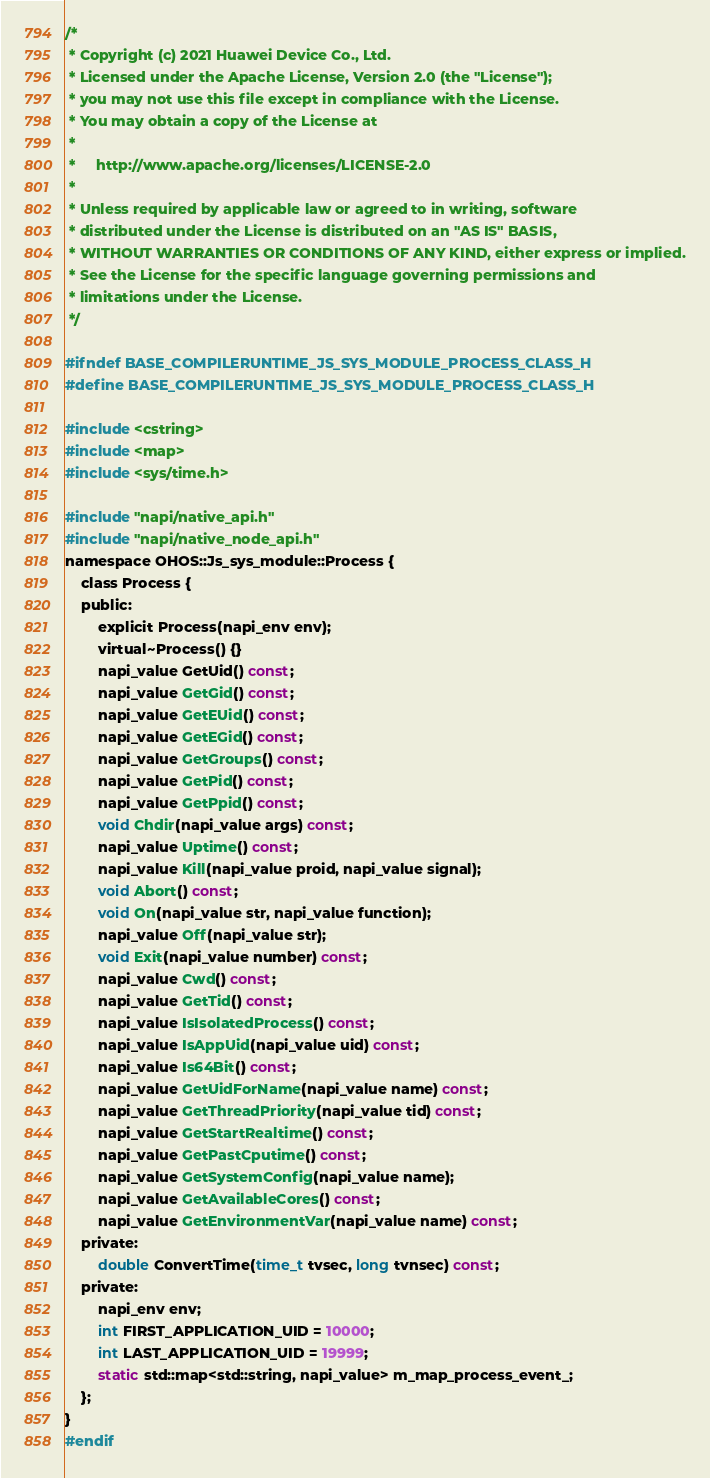Convert code to text. <code><loc_0><loc_0><loc_500><loc_500><_C_>/*
 * Copyright (c) 2021 Huawei Device Co., Ltd.
 * Licensed under the Apache License, Version 2.0 (the "License");
 * you may not use this file except in compliance with the License.
 * You may obtain a copy of the License at
 *
 *     http://www.apache.org/licenses/LICENSE-2.0
 *
 * Unless required by applicable law or agreed to in writing, software
 * distributed under the License is distributed on an "AS IS" BASIS,
 * WITHOUT WARRANTIES OR CONDITIONS OF ANY KIND, either express or implied.
 * See the License for the specific language governing permissions and
 * limitations under the License.
 */

#ifndef BASE_COMPILERUNTIME_JS_SYS_MODULE_PROCESS_CLASS_H
#define BASE_COMPILERUNTIME_JS_SYS_MODULE_PROCESS_CLASS_H

#include <cstring>
#include <map>
#include <sys/time.h>

#include "napi/native_api.h"
#include "napi/native_node_api.h"
namespace OHOS::Js_sys_module::Process {
    class Process {
    public:
        explicit Process(napi_env env);
        virtual~Process() {}
        napi_value GetUid() const;
        napi_value GetGid() const;
        napi_value GetEUid() const;
        napi_value GetEGid() const;
        napi_value GetGroups() const;
        napi_value GetPid() const;
        napi_value GetPpid() const;
        void Chdir(napi_value args) const;
        napi_value Uptime() const;
        napi_value Kill(napi_value proid, napi_value signal);
        void Abort() const;
        void On(napi_value str, napi_value function);
        napi_value Off(napi_value str);
        void Exit(napi_value number) const;
        napi_value Cwd() const;
        napi_value GetTid() const;
        napi_value IsIsolatedProcess() const;
        napi_value IsAppUid(napi_value uid) const;
        napi_value Is64Bit() const;
        napi_value GetUidForName(napi_value name) const;
        napi_value GetThreadPriority(napi_value tid) const;
        napi_value GetStartRealtime() const;
        napi_value GetPastCputime() const;
        napi_value GetSystemConfig(napi_value name);
        napi_value GetAvailableCores() const;
        napi_value GetEnvironmentVar(napi_value name) const;
    private:
        double ConvertTime(time_t tvsec, long tvnsec) const;
    private:
        napi_env env;
        int FIRST_APPLICATION_UID = 10000;
        int LAST_APPLICATION_UID = 19999;
        static std::map<std::string, napi_value> m_map_process_event_;
    };
}
#endif</code> 